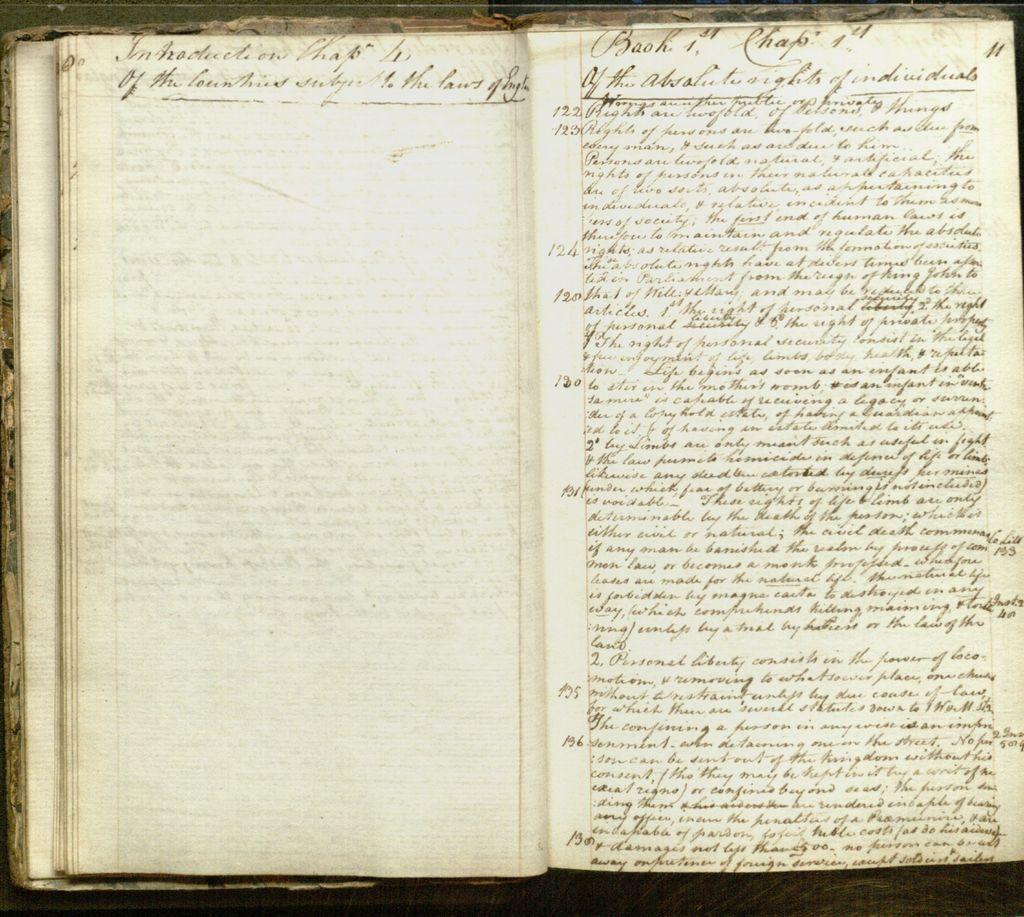How would you summarize this image in a sentence or two? In this image I can see a book and I can see the pages of the book are cream in color and something is written in the book with black color. 